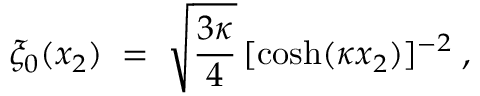<formula> <loc_0><loc_0><loc_500><loc_500>\xi _ { 0 } ( x _ { 2 } ) \, = \, \sqrt { \frac { 3 \kappa } { 4 } } \, [ \cosh ( \kappa x _ { 2 } ) ] ^ { - 2 } \, ,</formula> 